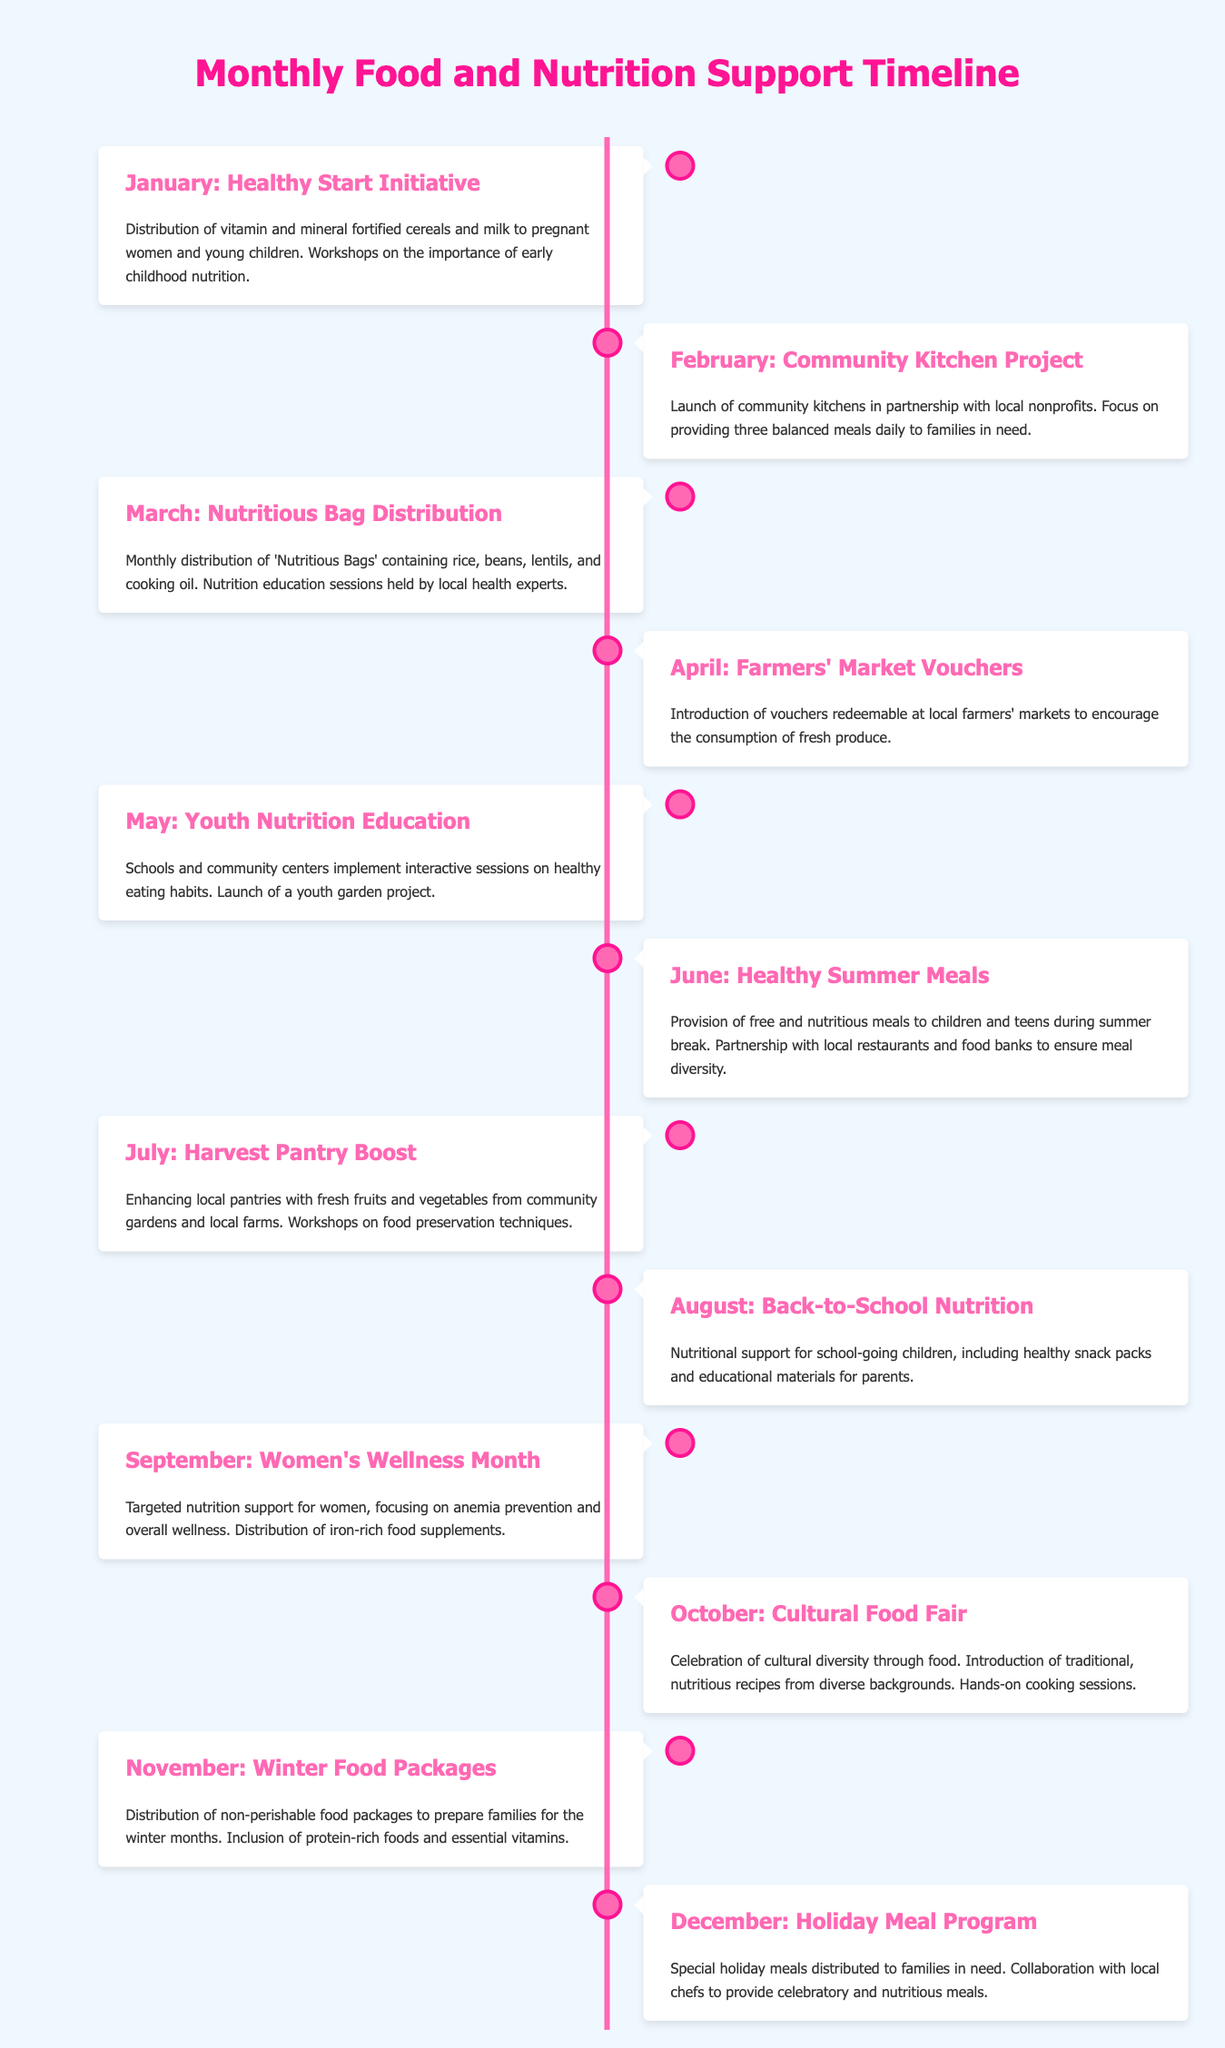What is the theme of January? The theme for January focuses on a Healthy Start Initiative, which includes the distribution of fortified cereals and workshops on early childhood nutrition.
Answer: Healthy Start Initiative What is distributed in March? In March, 'Nutritious Bags' containing rice, beans, lentils, and cooking oil are distributed along with nutrition education sessions.
Answer: Nutritious Bags Which month focuses on women’s wellness? September is dedicated to Women's Wellness Month, focusing on nutrition support for women.
Answer: September How many months include food distribution? Food distribution occurs in all twelve months, indicating continuous support for families in need throughout the year.
Answer: Twelve months What is the primary focus of the August initiative? The primary focus in August is on providing nutritional support for school-going children with healthy snacks.
Answer: Back-to-School Nutrition Which month features a cultural food celebration? October features a Cultural Food Fair that celebrates cultural diversity through traditional recipes and cooking sessions.
Answer: October In which month are community kitchens launched? Community kitchens are launched in February as part of the Community Kitchen Project.
Answer: February What type of education is provided in May? May emphasizes youth nutrition education, implementing interactive sessions on healthy eating habits.
Answer: Youth nutrition education 